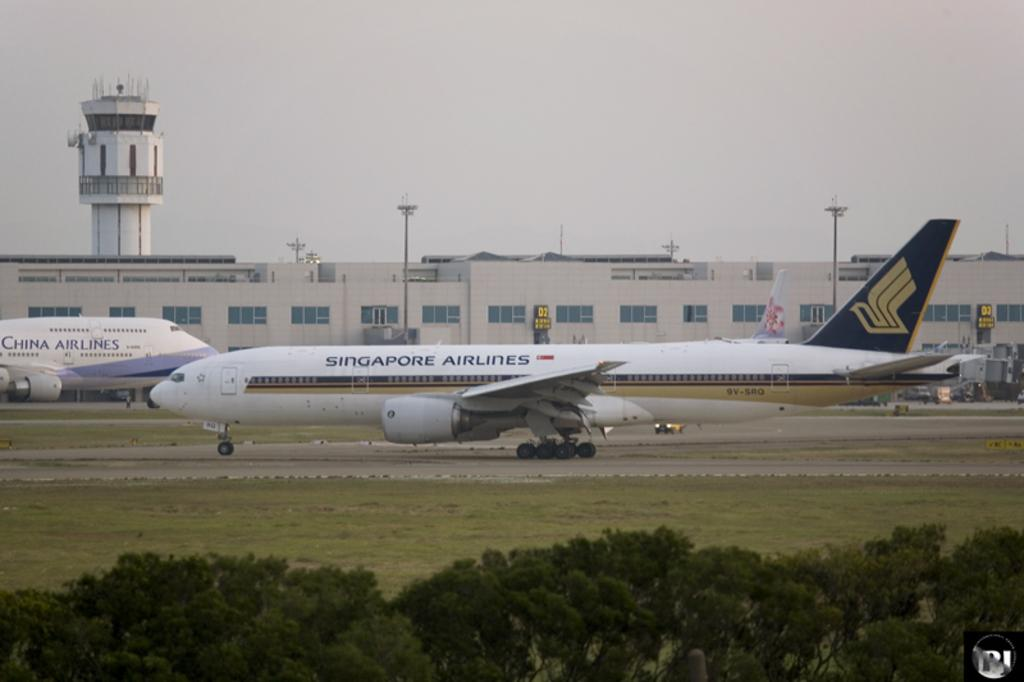<image>
Share a concise interpretation of the image provided. a plane is grounded on the strip from singapore airlines 